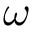<formula> <loc_0><loc_0><loc_500><loc_500>\omega</formula> 